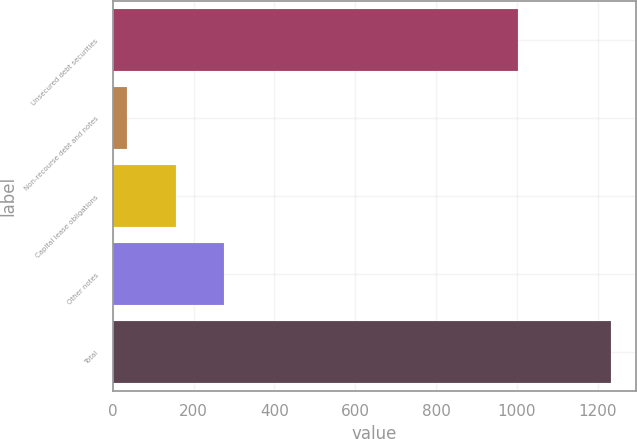Convert chart to OTSL. <chart><loc_0><loc_0><loc_500><loc_500><bar_chart><fcel>Unsecured debt securities<fcel>Non-recourse debt and notes<fcel>Capital lease obligations<fcel>Other notes<fcel>Total<nl><fcel>1004<fcel>36<fcel>155.8<fcel>275.6<fcel>1234<nl></chart> 